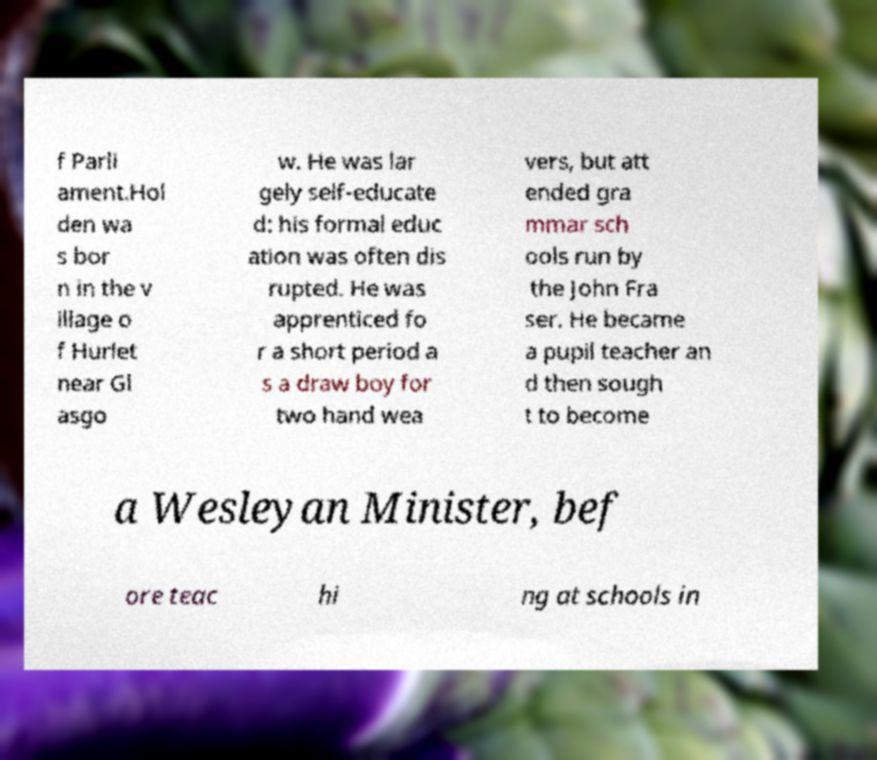What messages or text are displayed in this image? I need them in a readable, typed format. f Parli ament.Hol den wa s bor n in the v illage o f Hurlet near Gl asgo w. He was lar gely self-educate d: his formal educ ation was often dis rupted. He was apprenticed fo r a short period a s a draw boy for two hand wea vers, but att ended gra mmar sch ools run by the John Fra ser. He became a pupil teacher an d then sough t to become a Wesleyan Minister, bef ore teac hi ng at schools in 